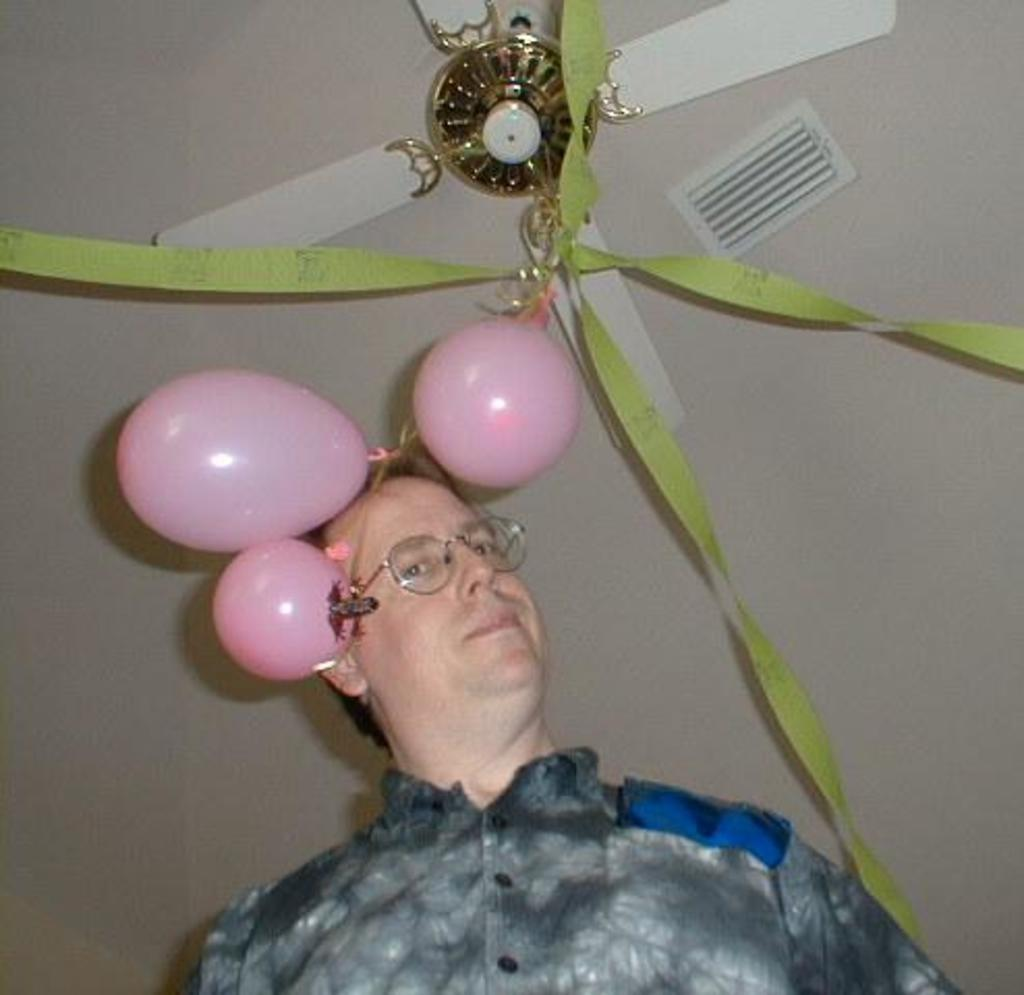Who is present in the image? There is a man in the image. What accessory is the man wearing? The man is wearing glasses. What can be seen in the background of the image? There are balloons, decorations, and a fan in the background of the image. What type of window can be seen in the image? There is no window present in the image. What sound can be heard coming from the fan in the image? The image is a still picture, so no sound can be heard. 